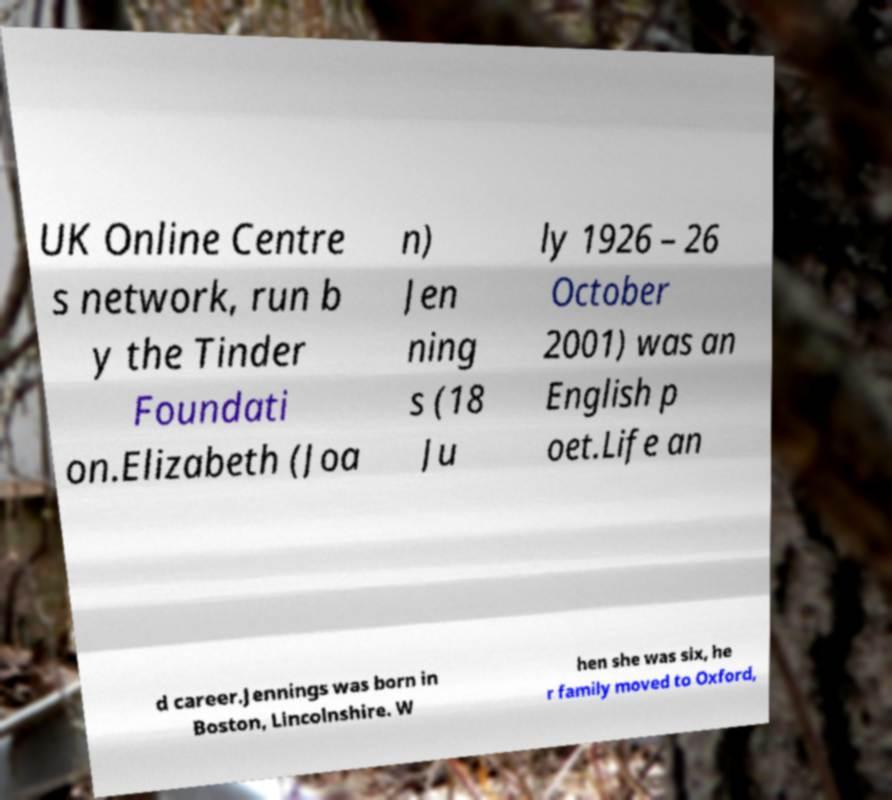Could you extract and type out the text from this image? UK Online Centre s network, run b y the Tinder Foundati on.Elizabeth (Joa n) Jen ning s (18 Ju ly 1926 – 26 October 2001) was an English p oet.Life an d career.Jennings was born in Boston, Lincolnshire. W hen she was six, he r family moved to Oxford, 